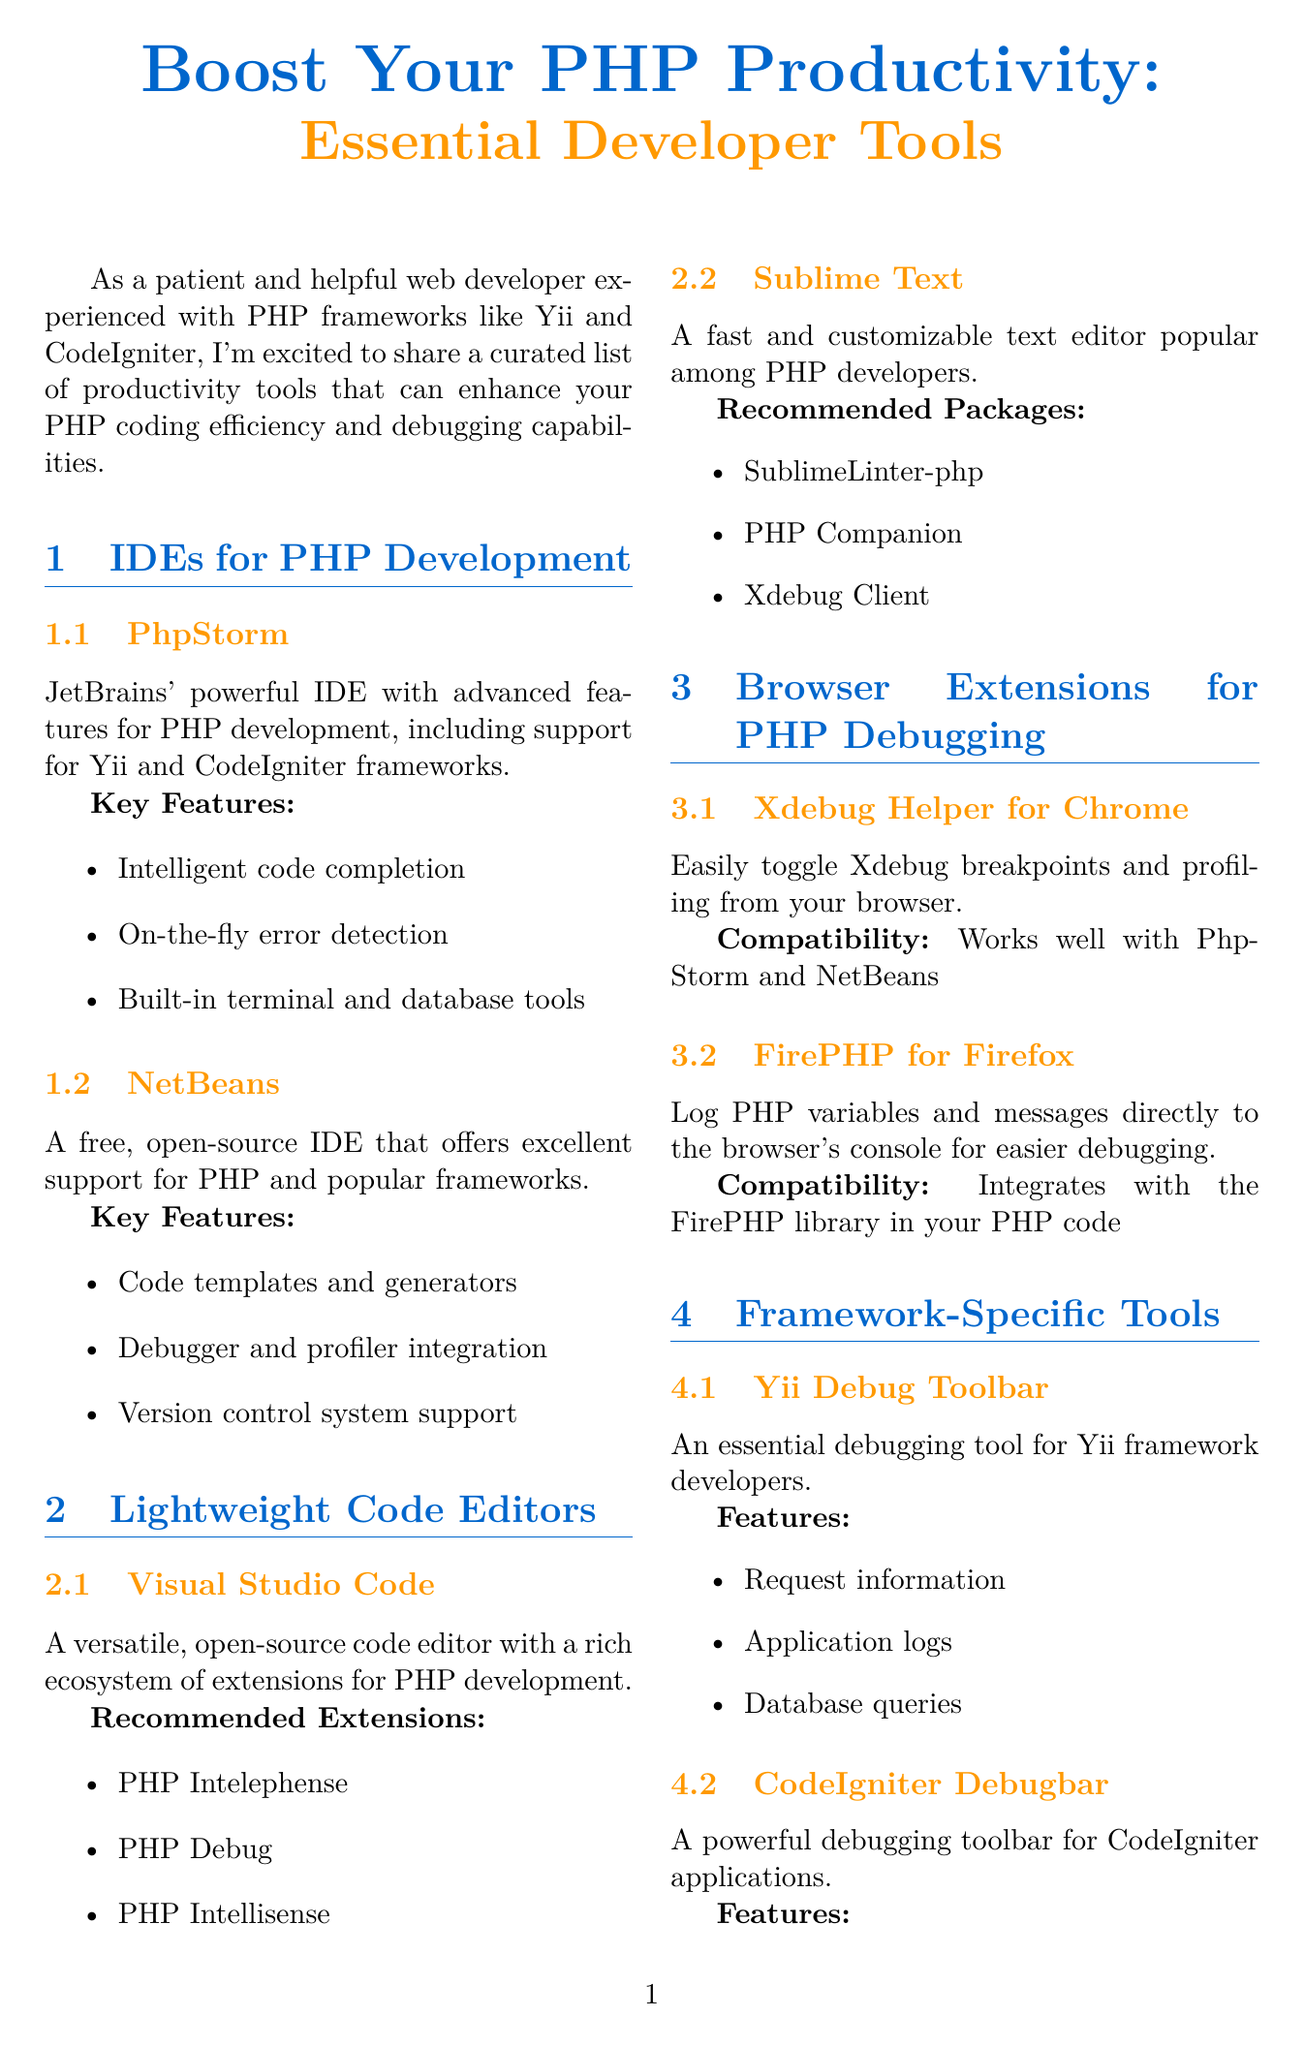What is the title of the newsletter? The title of the newsletter is stated at the beginning of the document.
Answer: Boost Your PHP Productivity: Essential Developer Tools What is the first IDE mentioned for PHP development? The first IDE listed under the section on IDEs for PHP Development is clearly stated.
Answer: PhpStorm Which key feature is specific to PhpStorm? The document lists multiple key features for PhpStorm, and one is highlighted as particularly advanced.
Answer: Intelligent code completion What is the recommended extension for Visual Studio Code? The document provides a list of recommended extensions for Visual Studio Code.
Answer: PHP Intelephense Which browser extension is compatible with PhpStorm? The document mentions compatibility for the Xdebug Helper extension in relation to PhpStorm.
Answer: Xdebug Helper for Chrome How many features does Yii Debug Toolbar provide? The document lists the features offered by the Yii Debug Toolbar.
Answer: Three What is the purpose of FirePHP for Firefox? The document explains what FirePHP for Firefox does, which relates to debugging.
Answer: Log PHP variables and messages directly to the browser's console What type of tool is CodeIgniter Debugbar? The document categorizes this tool under framework-specific tools, regarding debugging for CodeIgniter applications.
Answer: Debugging toolbar Which PHP frameworks are specifically mentioned in the newsletter? The newsletter introduces two PHP frameworks that are supported by the productivity tools.
Answer: Yii and CodeIgniter 